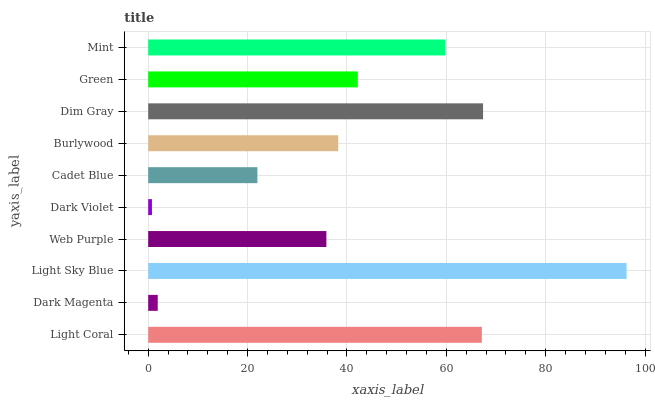Is Dark Violet the minimum?
Answer yes or no. Yes. Is Light Sky Blue the maximum?
Answer yes or no. Yes. Is Dark Magenta the minimum?
Answer yes or no. No. Is Dark Magenta the maximum?
Answer yes or no. No. Is Light Coral greater than Dark Magenta?
Answer yes or no. Yes. Is Dark Magenta less than Light Coral?
Answer yes or no. Yes. Is Dark Magenta greater than Light Coral?
Answer yes or no. No. Is Light Coral less than Dark Magenta?
Answer yes or no. No. Is Green the high median?
Answer yes or no. Yes. Is Burlywood the low median?
Answer yes or no. Yes. Is Dim Gray the high median?
Answer yes or no. No. Is Web Purple the low median?
Answer yes or no. No. 